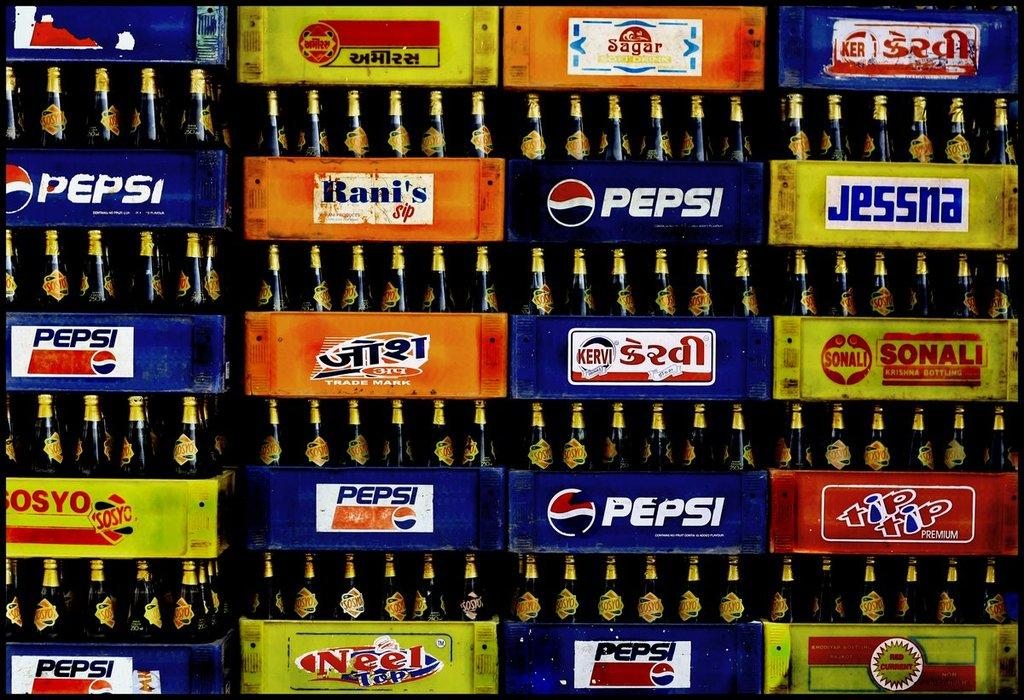<image>
Summarize the visual content of the image. Various cases of soda are displayed to include Pepsi, Rani's, and Sonali. 